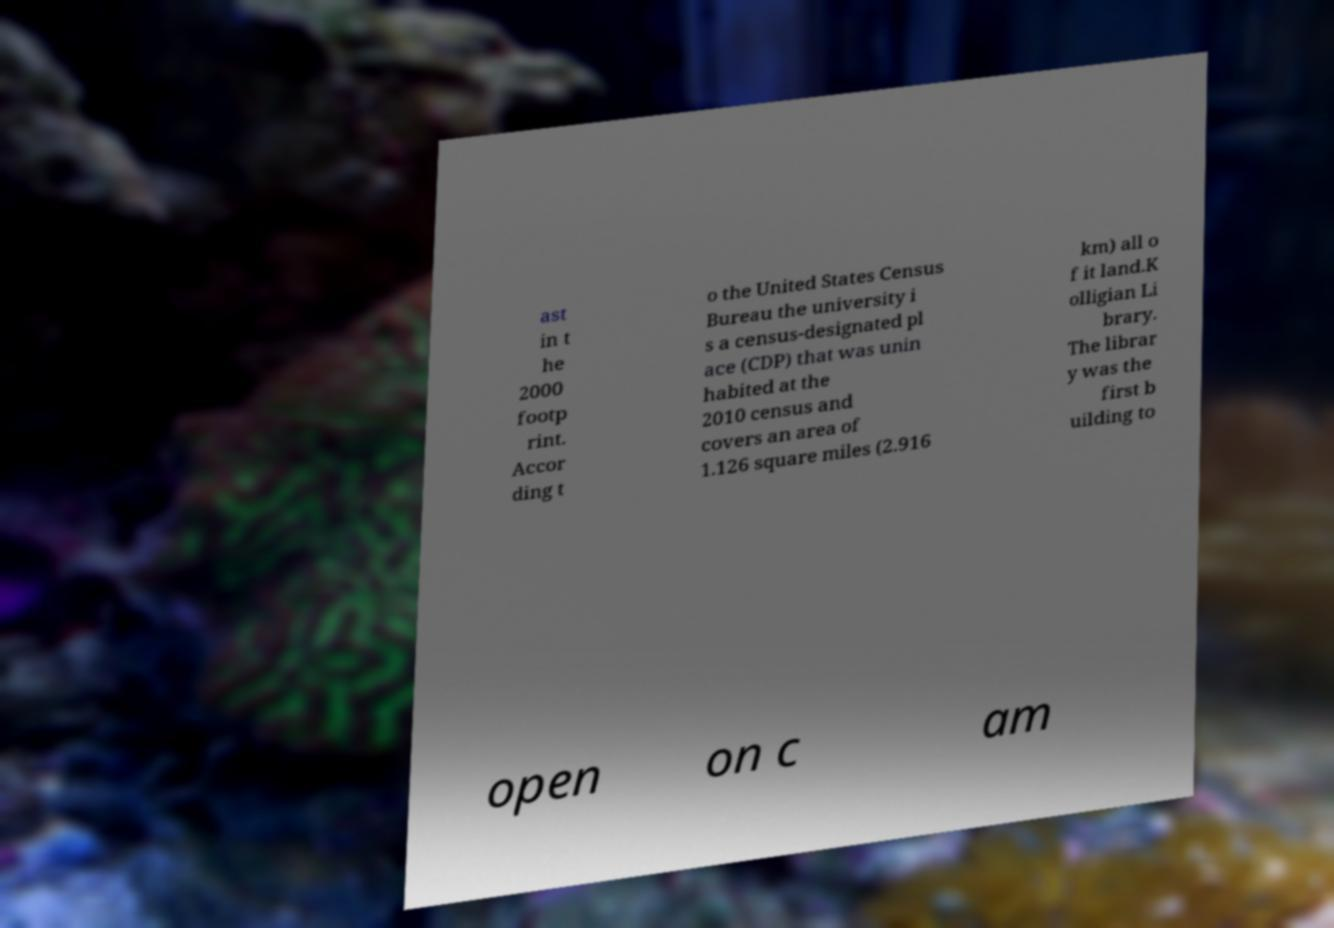Can you accurately transcribe the text from the provided image for me? ast in t he 2000 footp rint. Accor ding t o the United States Census Bureau the university i s a census-designated pl ace (CDP) that was unin habited at the 2010 census and covers an area of 1.126 square miles (2.916 km) all o f it land.K olligian Li brary. The librar y was the first b uilding to open on c am 